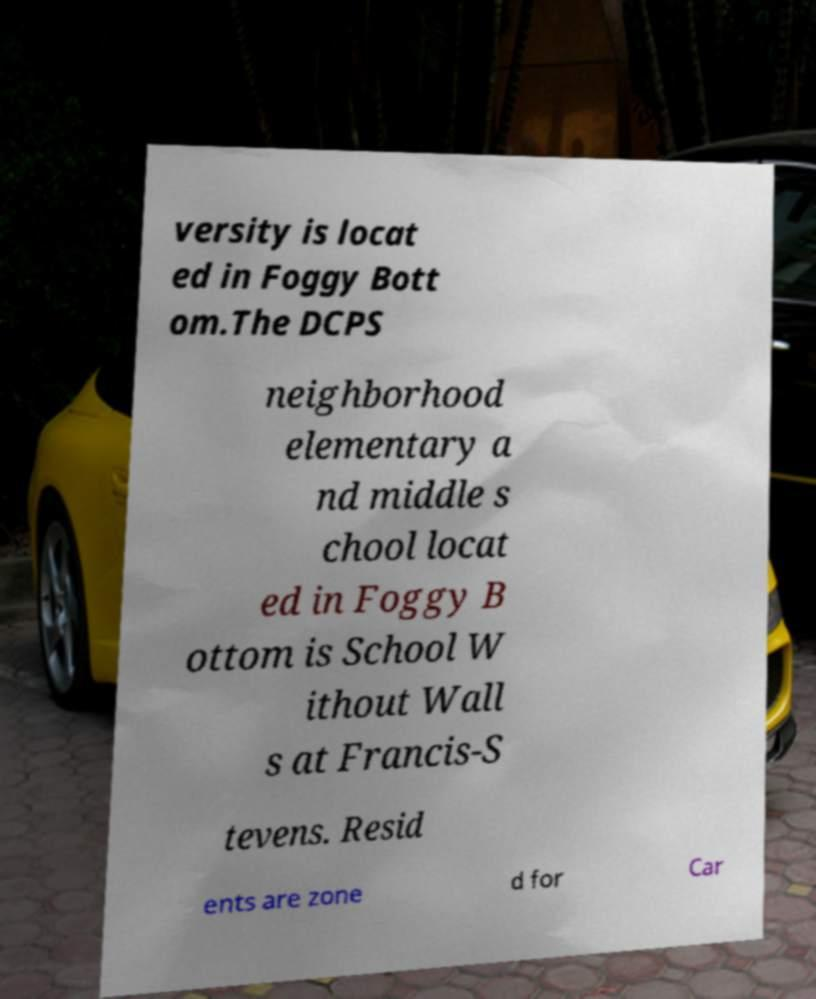Please read and relay the text visible in this image. What does it say? versity is locat ed in Foggy Bott om.The DCPS neighborhood elementary a nd middle s chool locat ed in Foggy B ottom is School W ithout Wall s at Francis-S tevens. Resid ents are zone d for Car 